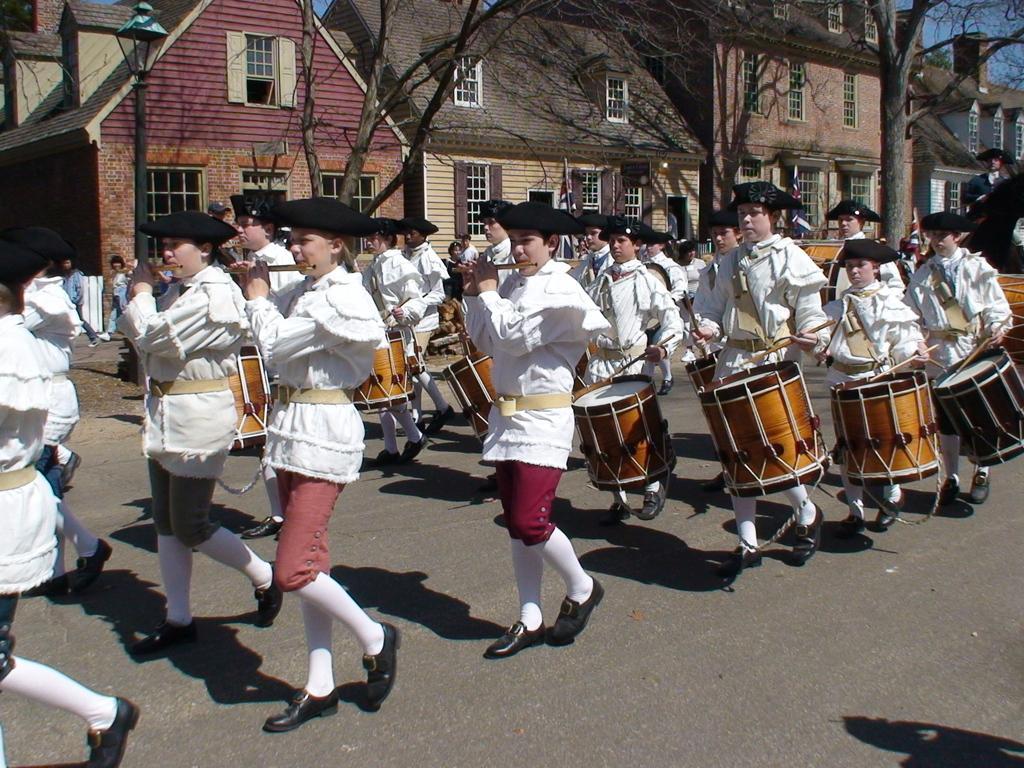Describe this image in one or two sentences. There is a group of people who are dressed in white and playing a snare drum with drum sticks. Here we can see a house and trees. 